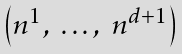<formula> <loc_0><loc_0><loc_500><loc_500>\begin{pmatrix} n ^ { 1 } , \ \dots , \ n ^ { d + 1 } \end{pmatrix}</formula> 